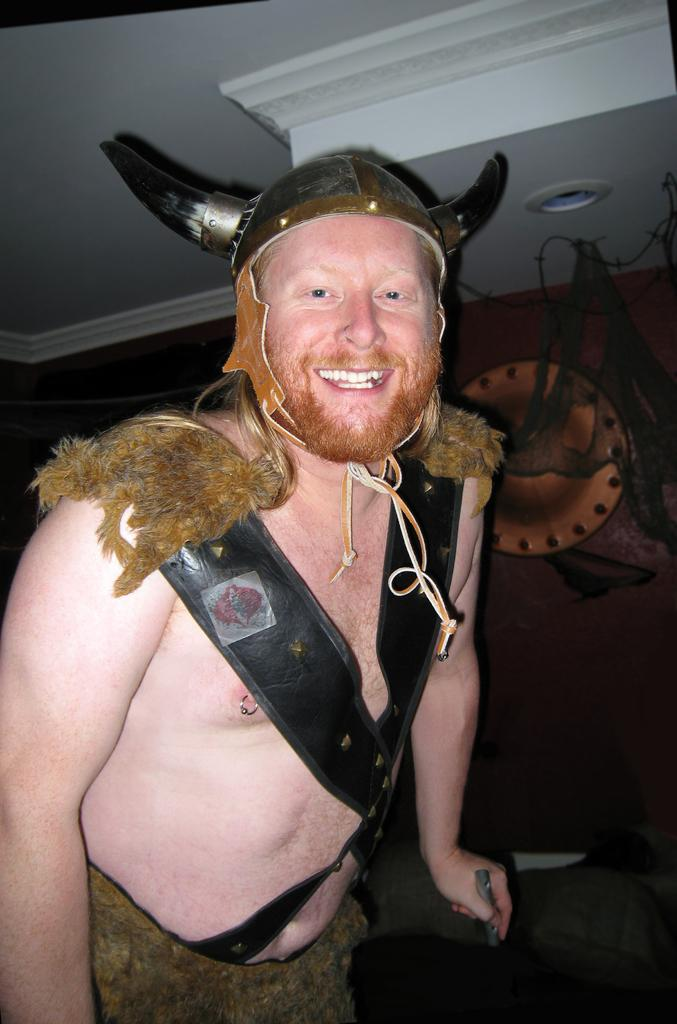What is the main subject of the image? There is a man in the image. What is the man doing in the image? The man is standing and smiling. What accessories is the man wearing in the image? The man is wearing temporary horns and fur on his body. What can be seen on the wall behind the man? There is something on the wall behind the man. What type of cream is the man using to perform the operation in the image? There is no cream or operation present in the image; the man is simply standing and smiling while wearing temporary horns and fur. 